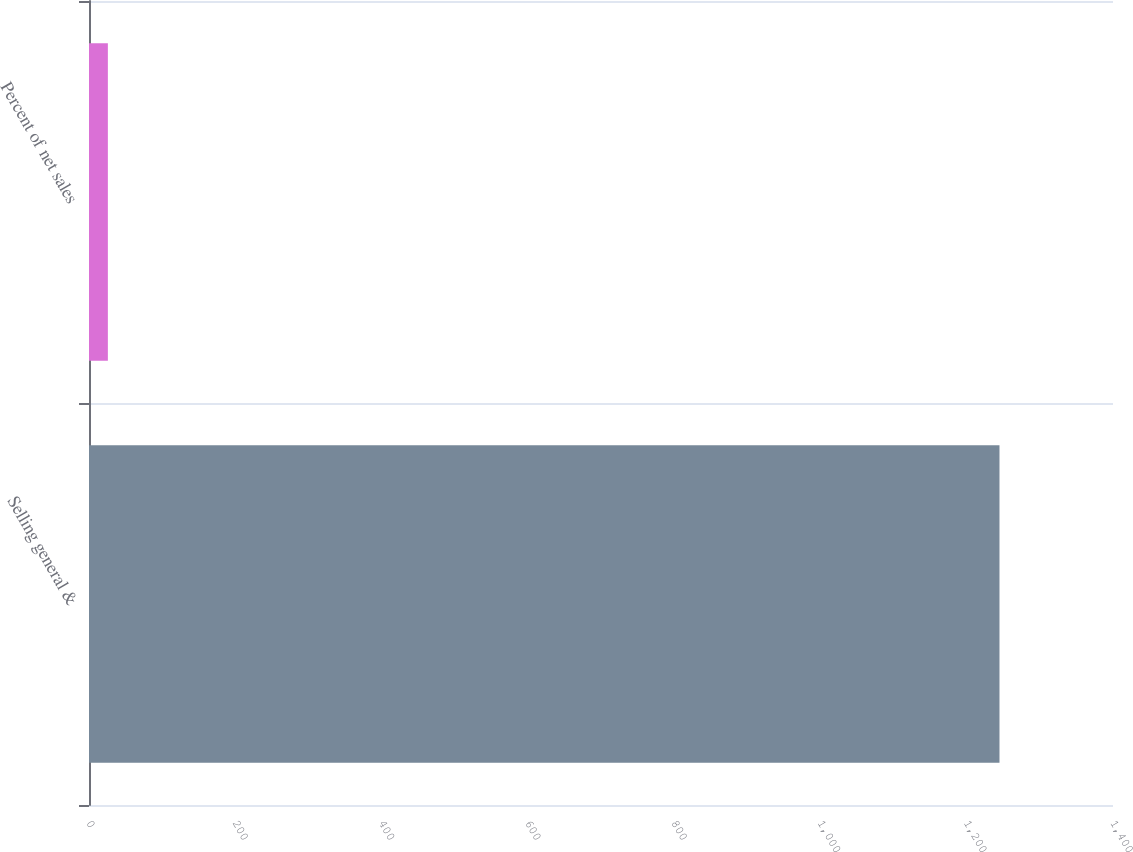Convert chart to OTSL. <chart><loc_0><loc_0><loc_500><loc_500><bar_chart><fcel>Selling general &<fcel>Percent of net sales<nl><fcel>1244.8<fcel>25.8<nl></chart> 